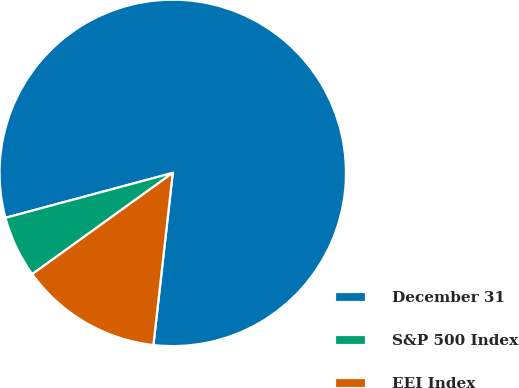<chart> <loc_0><loc_0><loc_500><loc_500><pie_chart><fcel>December 31<fcel>S&P 500 Index<fcel>EEI Index<nl><fcel>80.95%<fcel>5.76%<fcel>13.28%<nl></chart> 